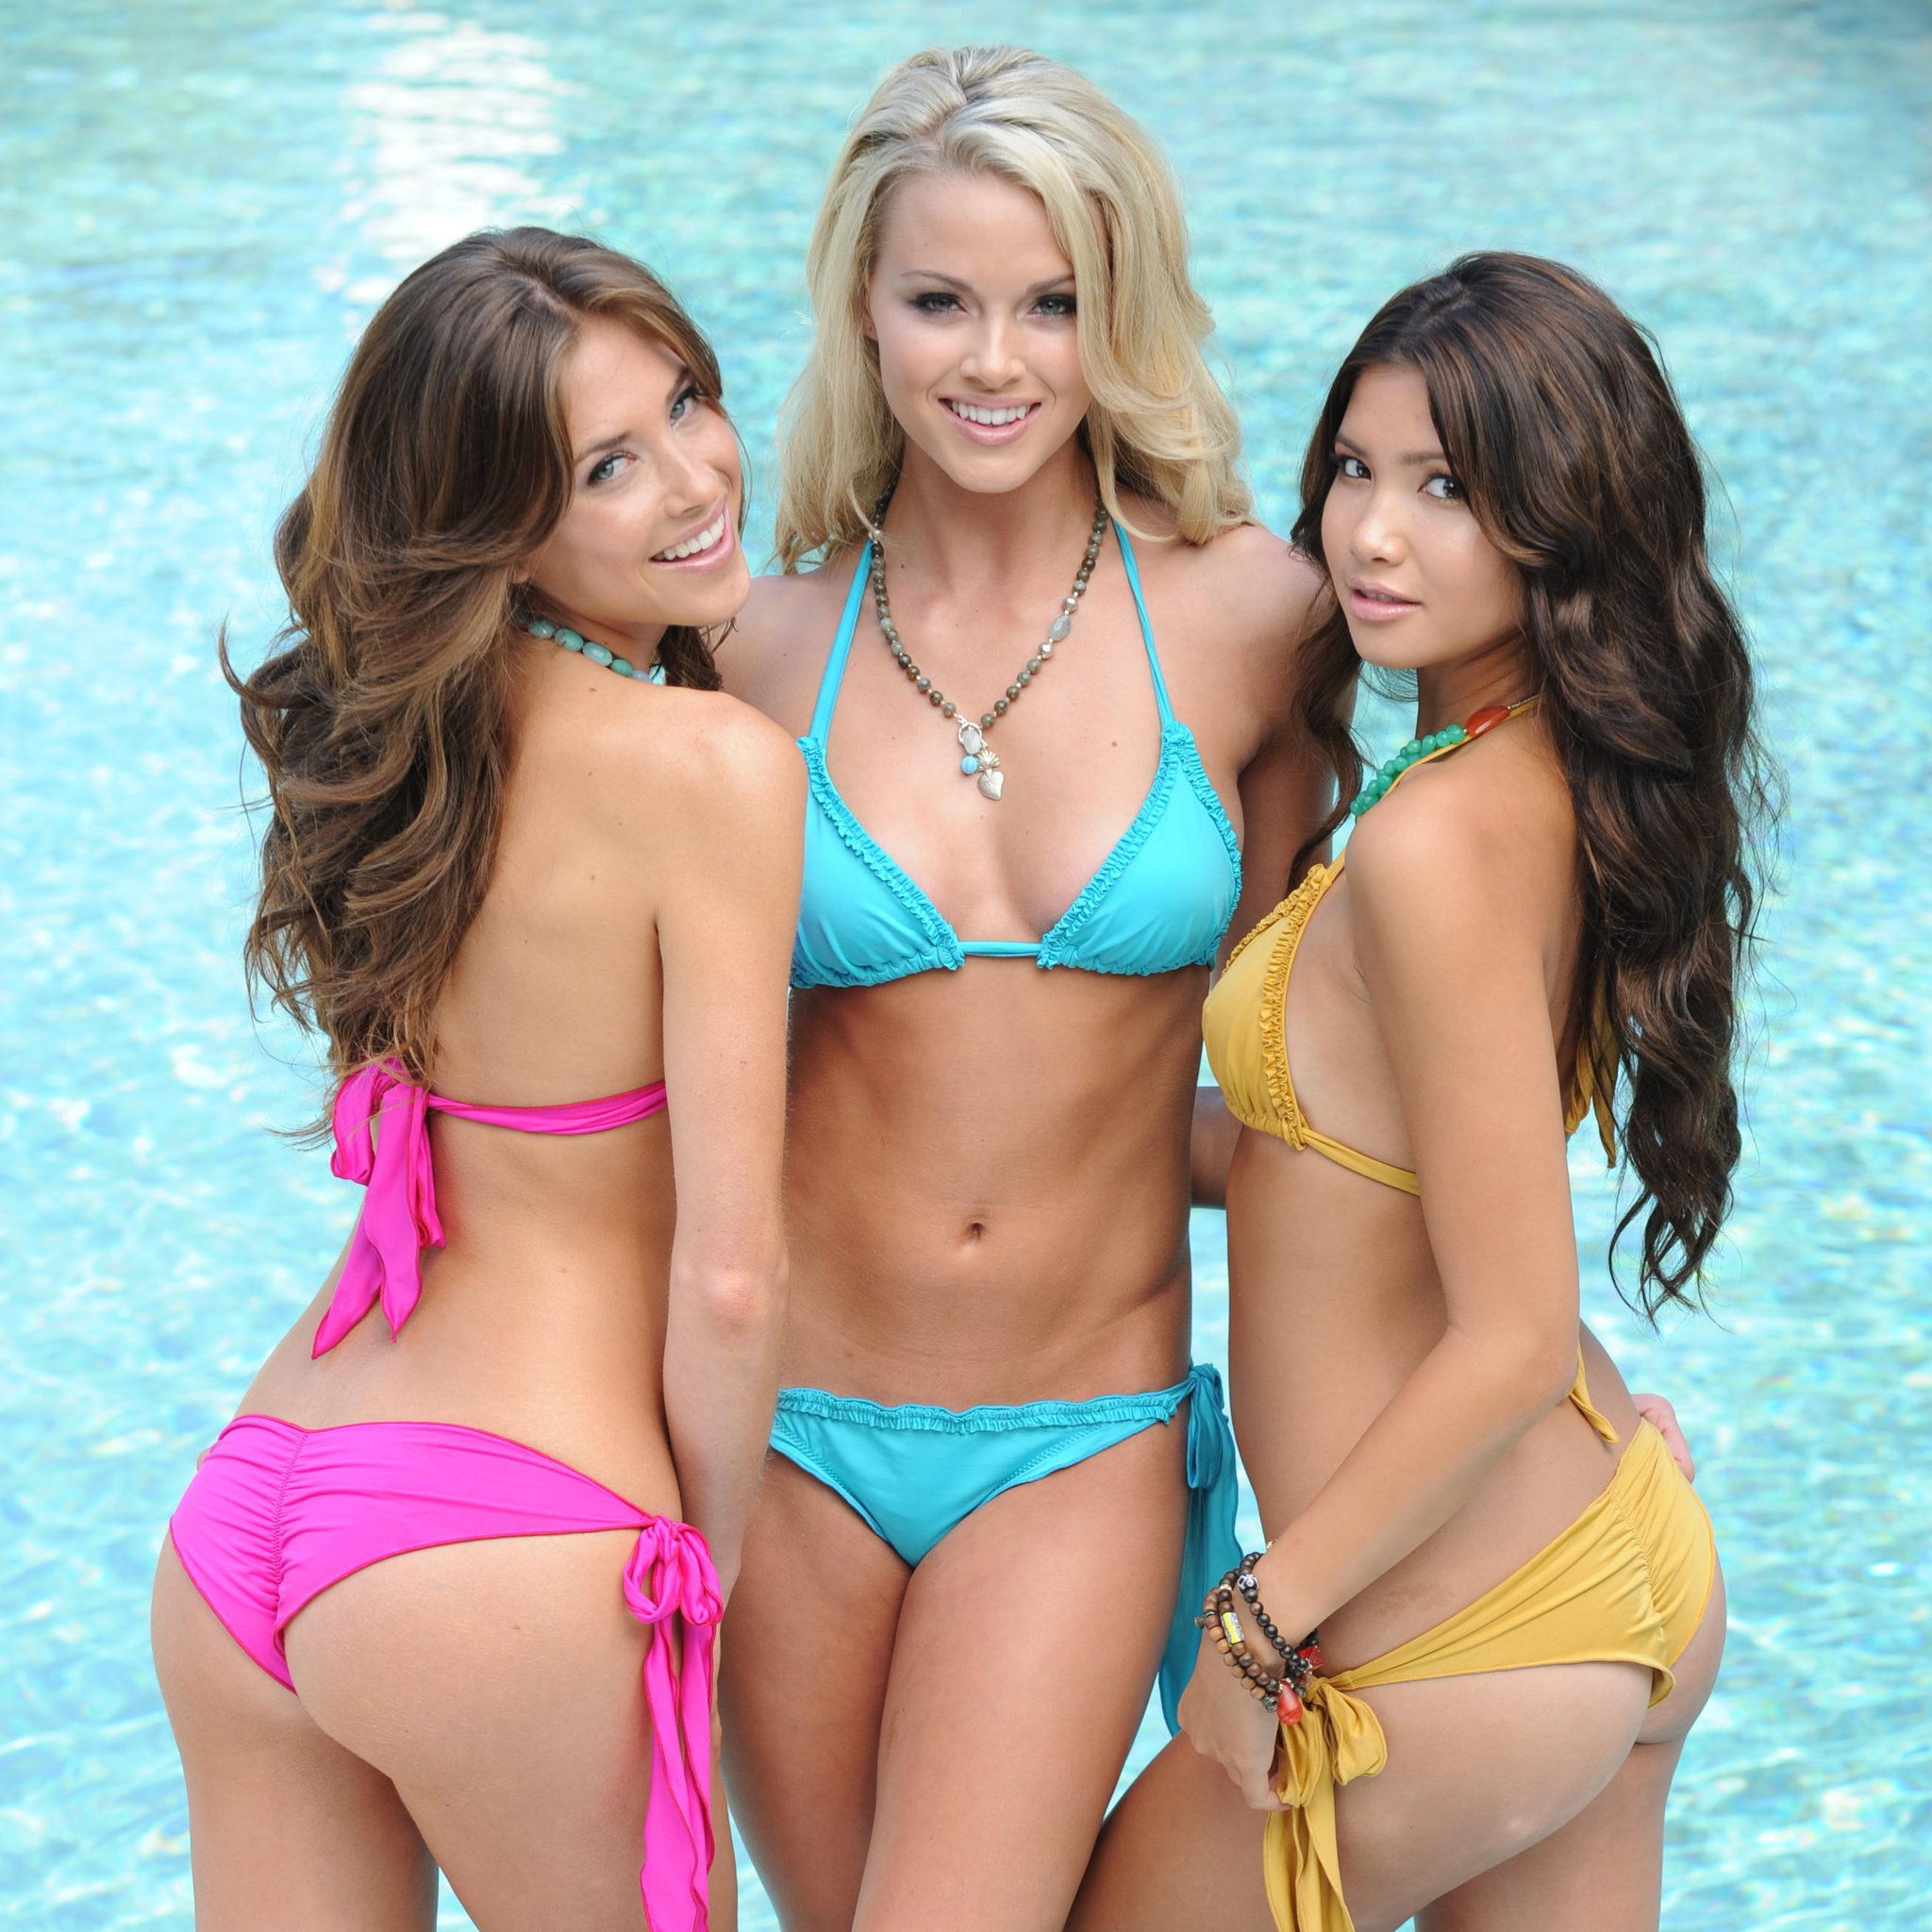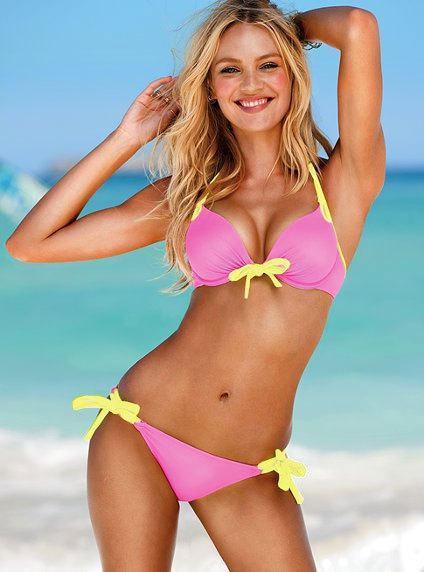The first image is the image on the left, the second image is the image on the right. For the images shown, is this caption "An image shows a rear view of a bikini and a forward view." true? Answer yes or no. Yes. 